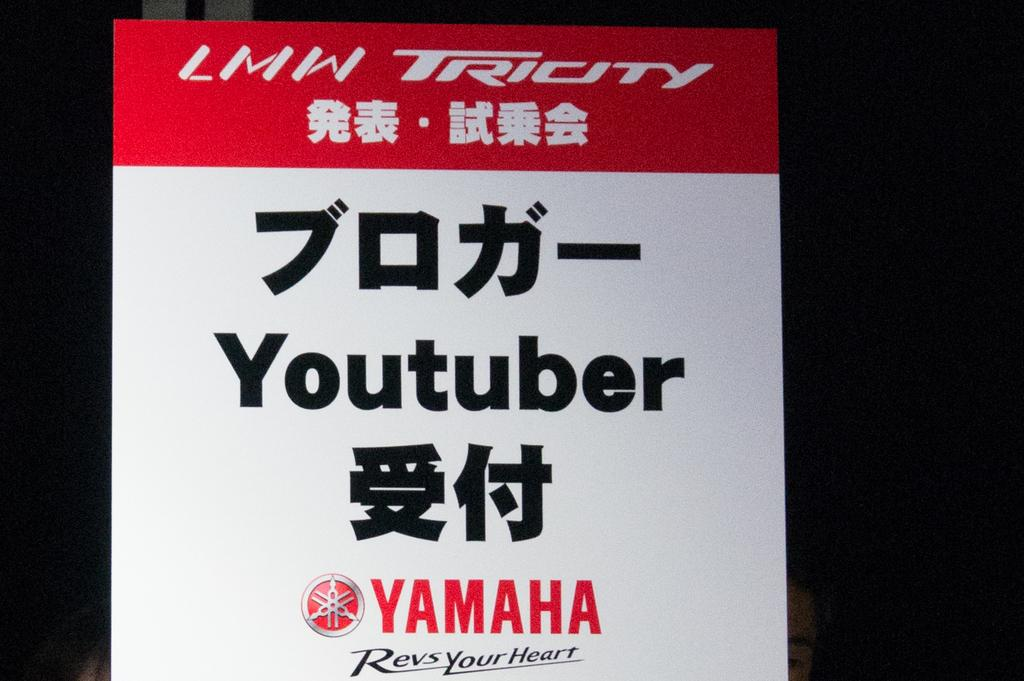<image>
Offer a succinct explanation of the picture presented. A white and red Yamaha endorsement for a YouTuber sign. 